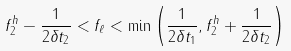Convert formula to latex. <formula><loc_0><loc_0><loc_500><loc_500>f ^ { h } _ { 2 } - \frac { 1 } { 2 \delta { t } _ { 2 } } < f _ { \ell } < \min \left ( \frac { 1 } { 2 \delta { t } _ { 1 } } , f ^ { h } _ { 2 } + \frac { 1 } { 2 \delta { t } _ { 2 } } \right )</formula> 